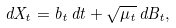Convert formula to latex. <formula><loc_0><loc_0><loc_500><loc_500>d X _ { t } = b _ { t } \, d t + \sqrt { \mu _ { t } } \, d B _ { t } ,</formula> 